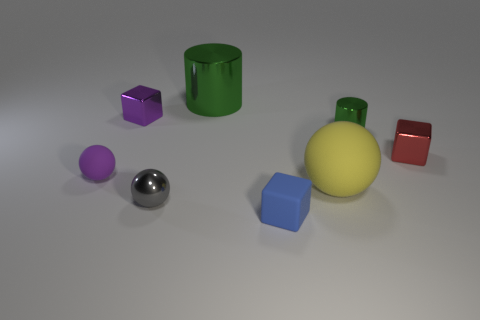There is a block left of the green cylinder on the left side of the large yellow ball; what is its material?
Your response must be concise. Metal. The purple rubber ball has what size?
Your response must be concise. Small. What size is the ball that is the same material as the small green cylinder?
Provide a succinct answer. Small. There is a matte ball that is in front of the purple rubber sphere; is it the same size as the big green shiny thing?
Give a very brief answer. Yes. There is a matte object in front of the rubber ball that is to the right of the tiny rubber sphere that is to the left of the gray ball; what shape is it?
Give a very brief answer. Cube. How many objects are tiny rubber cubes or matte balls that are in front of the purple matte object?
Your answer should be very brief. 2. What is the size of the shiny cylinder that is in front of the large green cylinder?
Provide a short and direct response. Small. What shape is the thing that is the same color as the small matte sphere?
Ensure brevity in your answer.  Cube. Is the purple sphere made of the same material as the large thing in front of the red thing?
Ensure brevity in your answer.  Yes. What number of rubber balls are to the left of the metallic thing to the left of the metallic sphere that is in front of the purple sphere?
Provide a short and direct response. 1. 